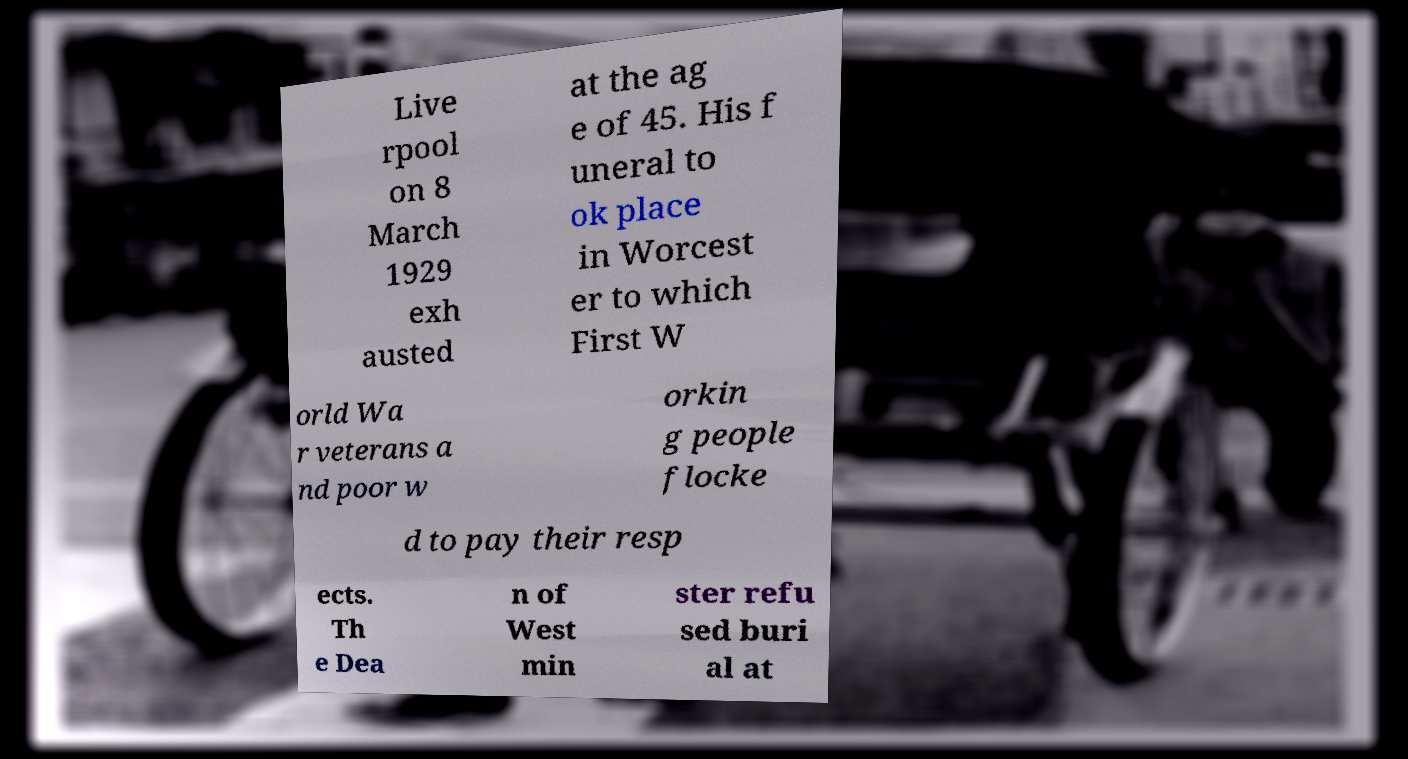There's text embedded in this image that I need extracted. Can you transcribe it verbatim? Live rpool on 8 March 1929 exh austed at the ag e of 45. His f uneral to ok place in Worcest er to which First W orld Wa r veterans a nd poor w orkin g people flocke d to pay their resp ects. Th e Dea n of West min ster refu sed buri al at 